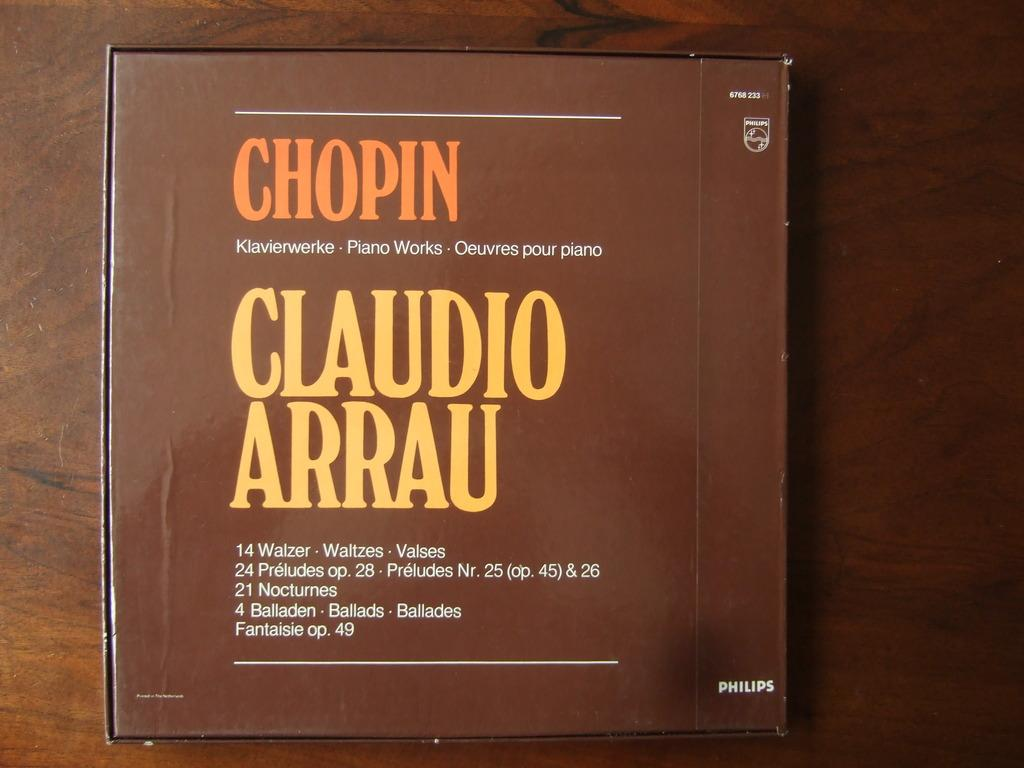<image>
Render a clear and concise summary of the photo. A brown cover for Chopin and Claudio Arrau. 